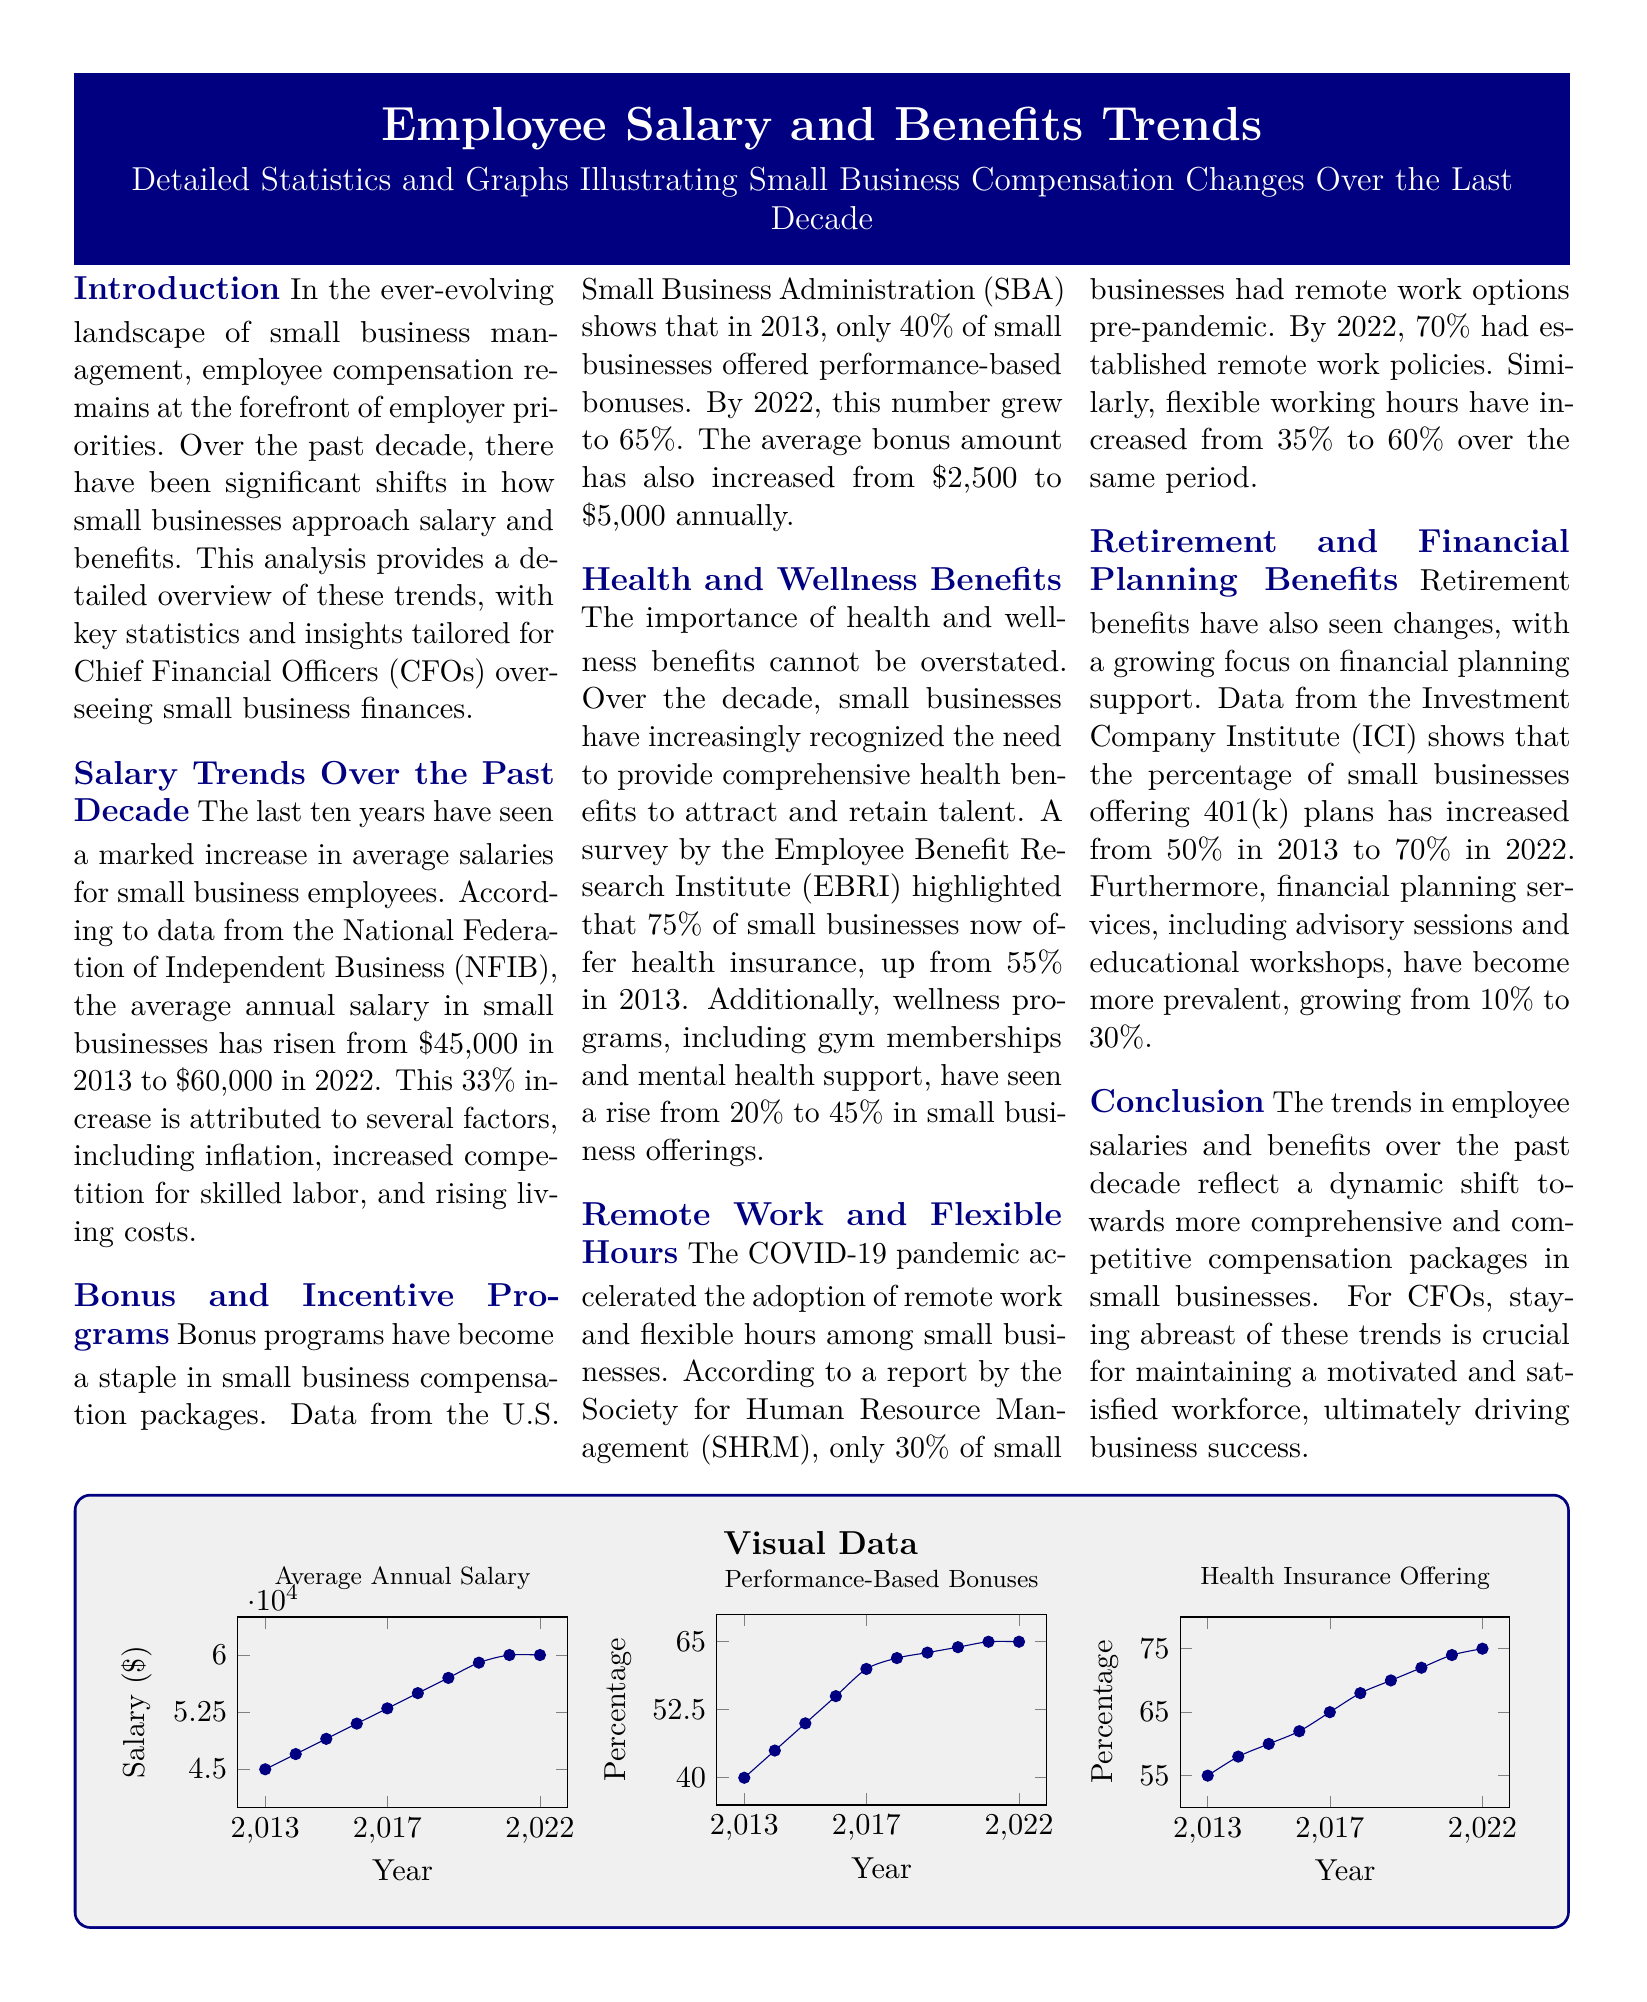What was the average annual salary in 2013? The average annual salary in small businesses in 2013 was reported in the salary trends section.
Answer: $45,000 What is the percentage of small businesses offering health insurance in 2022? The document mentions the percentage of small businesses offering health insurance as of 2022 in the health benefits section.
Answer: 75% How much did the average bonus amount increase to by 2022? The increase in average bonus amount from 2013 to 2022 is provided in the bonus programs section of the document.
Answer: $5,000 What percentage of small businesses had remote work options pre-pandemic? The percentage of small businesses offering remote work options before the pandemic is given in the remote work section.
Answer: 30% By how much did the percentage of businesses offering 401(k) plans increase from 2013 to 2022? This increase is specifically noted in the retirement benefits section with a comparison of years.
Answer: 20% What year saw the average annual salary first reach $60,000? The timeline for the average annual salary is included in the salary trends section of the document.
Answer: 2022 What percentage of small businesses offered performance-based bonuses in 2013? The percentage of businesses offering performance-based bonuses in 2013 is specified in the bonus programs section.
Answer: 40% What is the main focus of the document? The overall theme and purpose of the document is outlined in the introduction section, emphasizing a specific area of concern.
Answer: Employee compensation trends What type of analysis does the document provide? The type of analysis offered is detailed in the introductory text, indicating the focus area.
Answer: Detailed statistics and graphs 